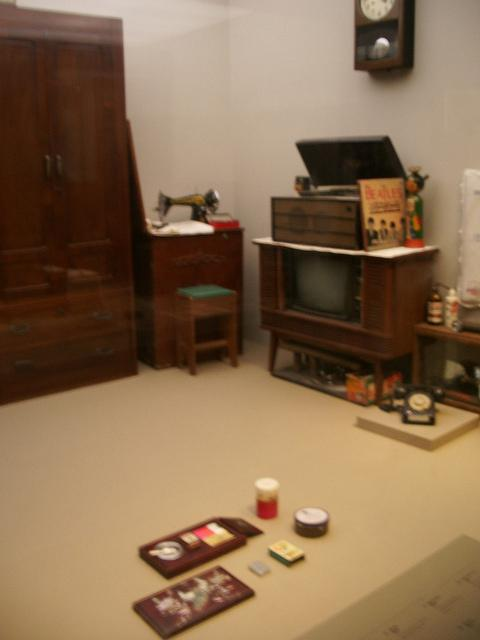What is able to be repaired by the machine in the corner? Please explain your reasoning. clothing. A sewing machine can stitch cloth together. 